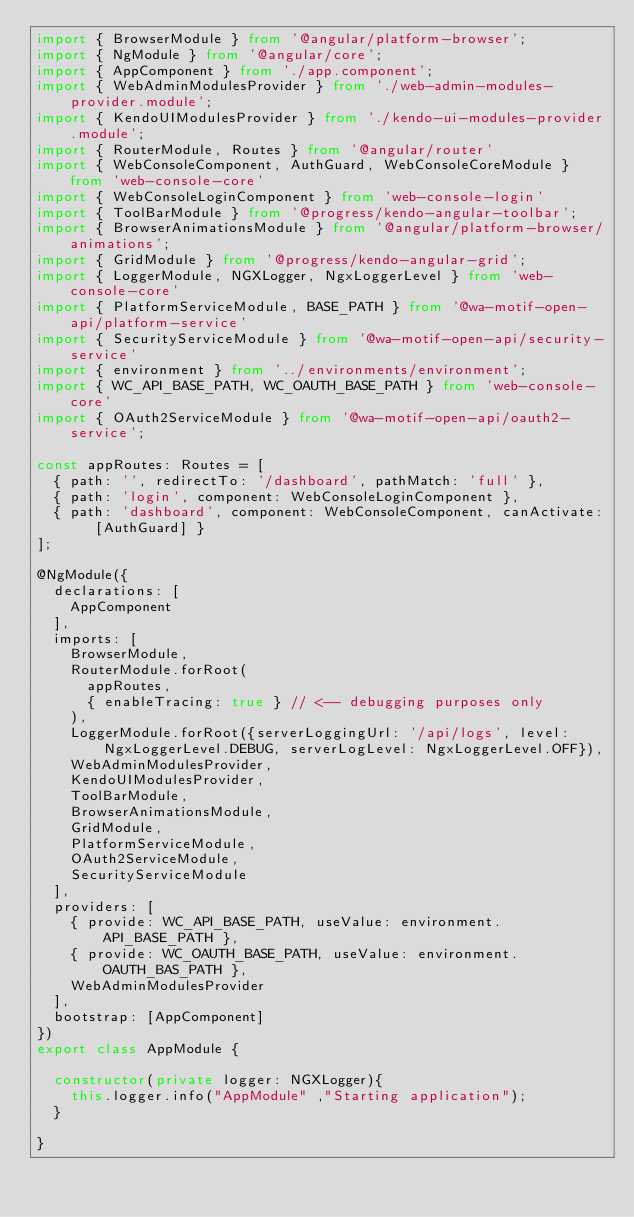<code> <loc_0><loc_0><loc_500><loc_500><_TypeScript_>import { BrowserModule } from '@angular/platform-browser';
import { NgModule } from '@angular/core';
import { AppComponent } from './app.component';
import { WebAdminModulesProvider } from './web-admin-modules-provider.module';
import { KendoUIModulesProvider } from './kendo-ui-modules-provider.module';
import { RouterModule, Routes } from '@angular/router'
import { WebConsoleComponent, AuthGuard, WebConsoleCoreModule } from 'web-console-core'
import { WebConsoleLoginComponent } from 'web-console-login'
import { ToolBarModule } from '@progress/kendo-angular-toolbar';
import { BrowserAnimationsModule } from '@angular/platform-browser/animations';
import { GridModule } from '@progress/kendo-angular-grid';
import { LoggerModule, NGXLogger, NgxLoggerLevel } from 'web-console-core'
import { PlatformServiceModule, BASE_PATH } from '@wa-motif-open-api/platform-service'
import { SecurityServiceModule } from '@wa-motif-open-api/security-service'
import { environment } from '../environments/environment';
import { WC_API_BASE_PATH, WC_OAUTH_BASE_PATH } from 'web-console-core'
import { OAuth2ServiceModule } from '@wa-motif-open-api/oauth2-service';

const appRoutes: Routes = [
  { path: '', redirectTo: '/dashboard', pathMatch: 'full' },
  { path: 'login', component: WebConsoleLoginComponent },
  { path: 'dashboard', component: WebConsoleComponent, canActivate: [AuthGuard] }
];

@NgModule({
  declarations: [
    AppComponent 
  ],
  imports: [
    BrowserModule,  
    RouterModule.forRoot(
      appRoutes,
      { enableTracing: true } // <-- debugging purposes only
    ),
    LoggerModule.forRoot({serverLoggingUrl: '/api/logs', level: NgxLoggerLevel.DEBUG, serverLogLevel: NgxLoggerLevel.OFF}),
    WebAdminModulesProvider, 
    KendoUIModulesProvider, 
    ToolBarModule, 
    BrowserAnimationsModule, 
    GridModule,
    PlatformServiceModule,
    OAuth2ServiceModule,
    SecurityServiceModule
  ],
  providers: [ 
    { provide: WC_API_BASE_PATH, useValue: environment.API_BASE_PATH }, 
    { provide: WC_OAUTH_BASE_PATH, useValue: environment.OAUTH_BAS_PATH },
    WebAdminModulesProvider
  ],
  bootstrap: [AppComponent]
})
export class AppModule { 

  constructor(private logger: NGXLogger){
    this.logger.info("AppModule" ,"Starting application");
  }

}
</code> 